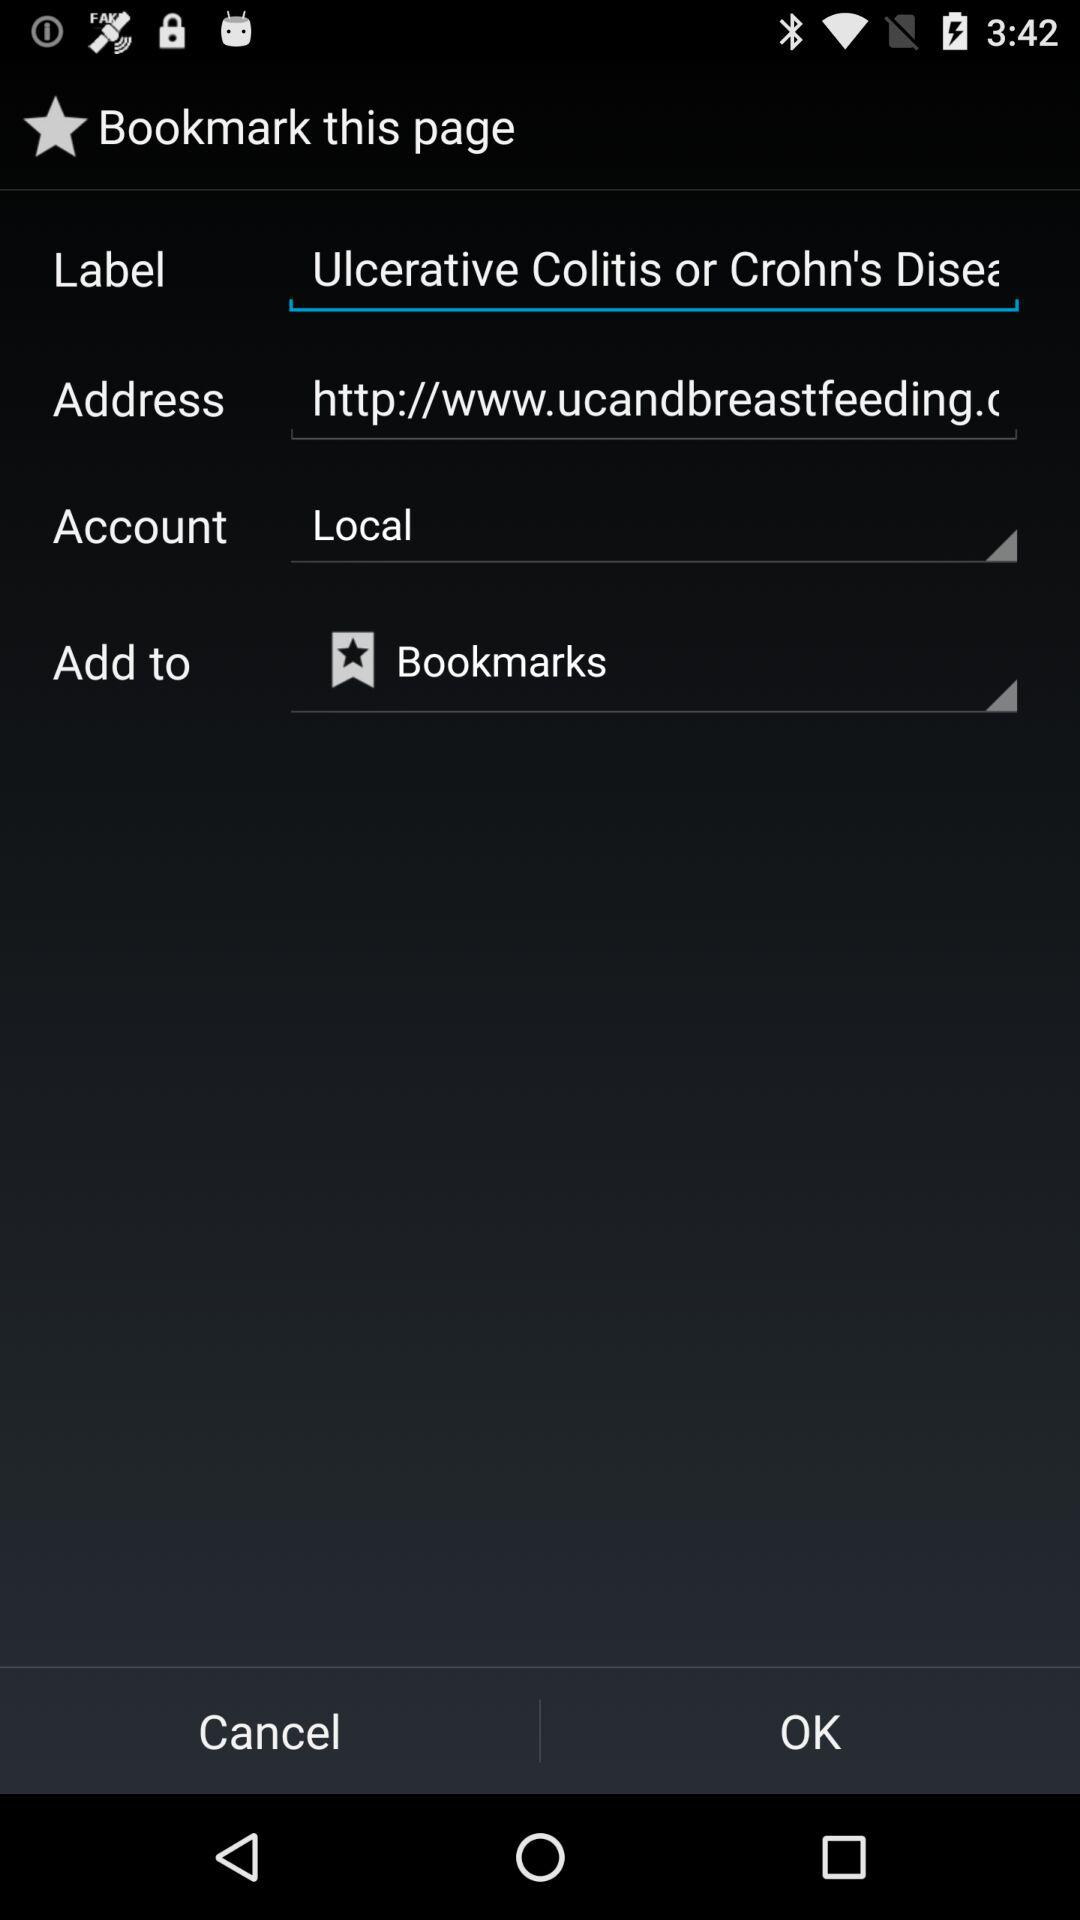Which other account options are there?
When the provided information is insufficient, respond with <no answer>. <no answer> 